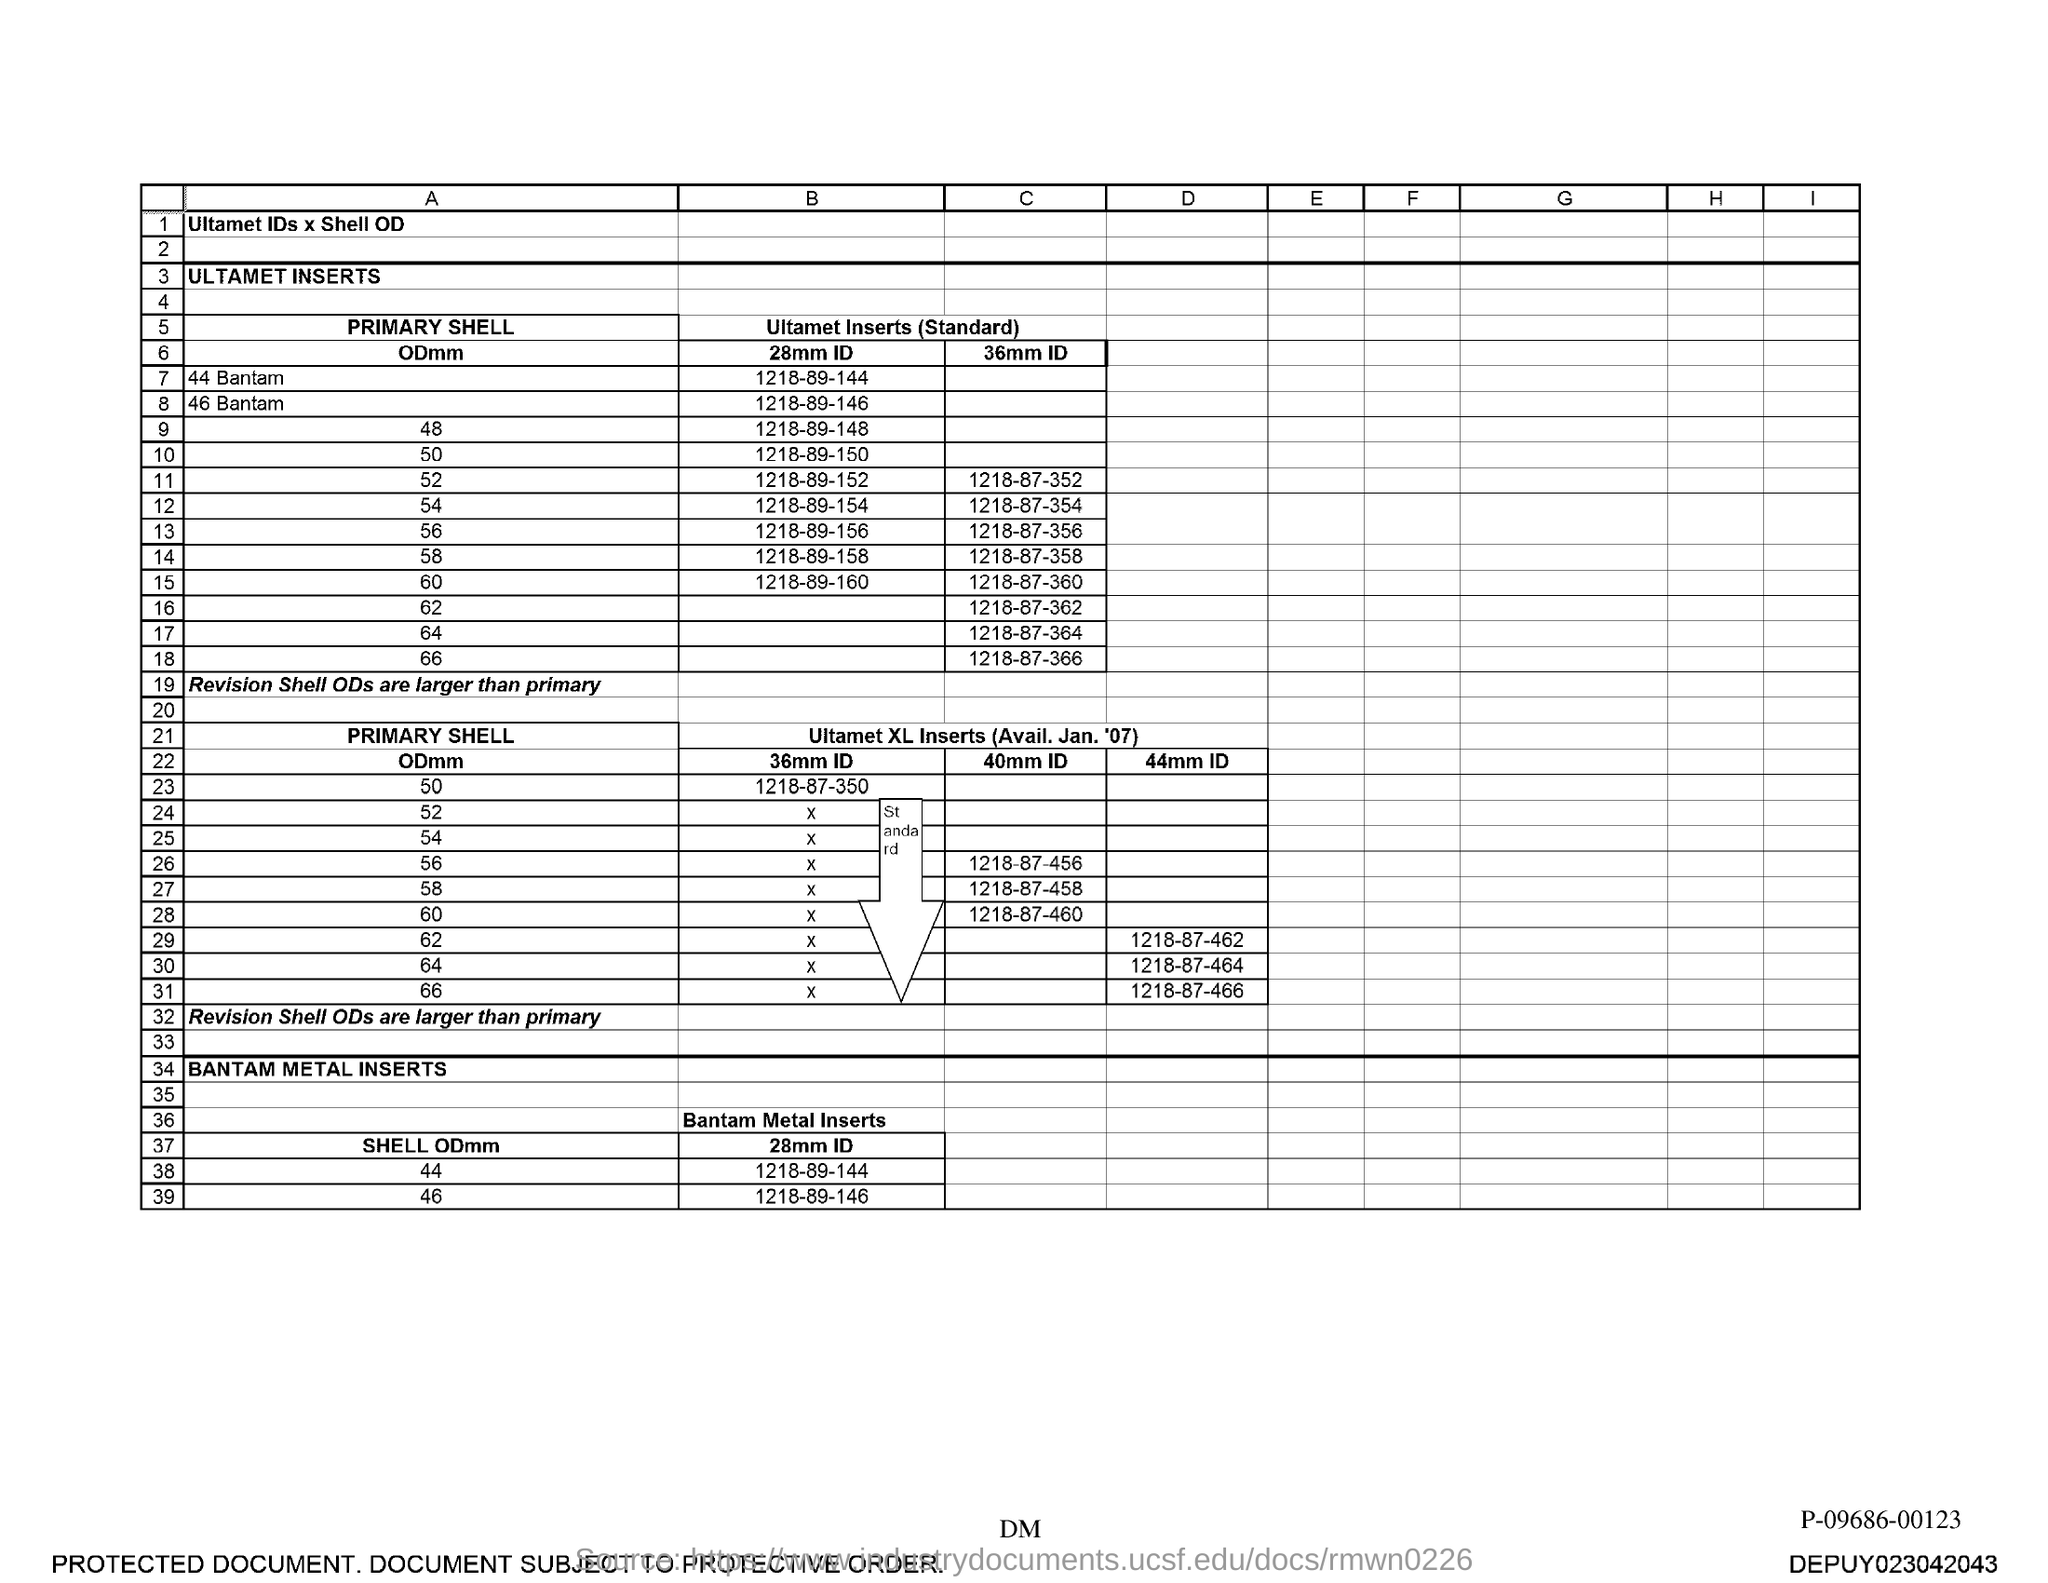What is the 28mm ID for shell ODmm 44?
Keep it short and to the point. 1218-89-144. 